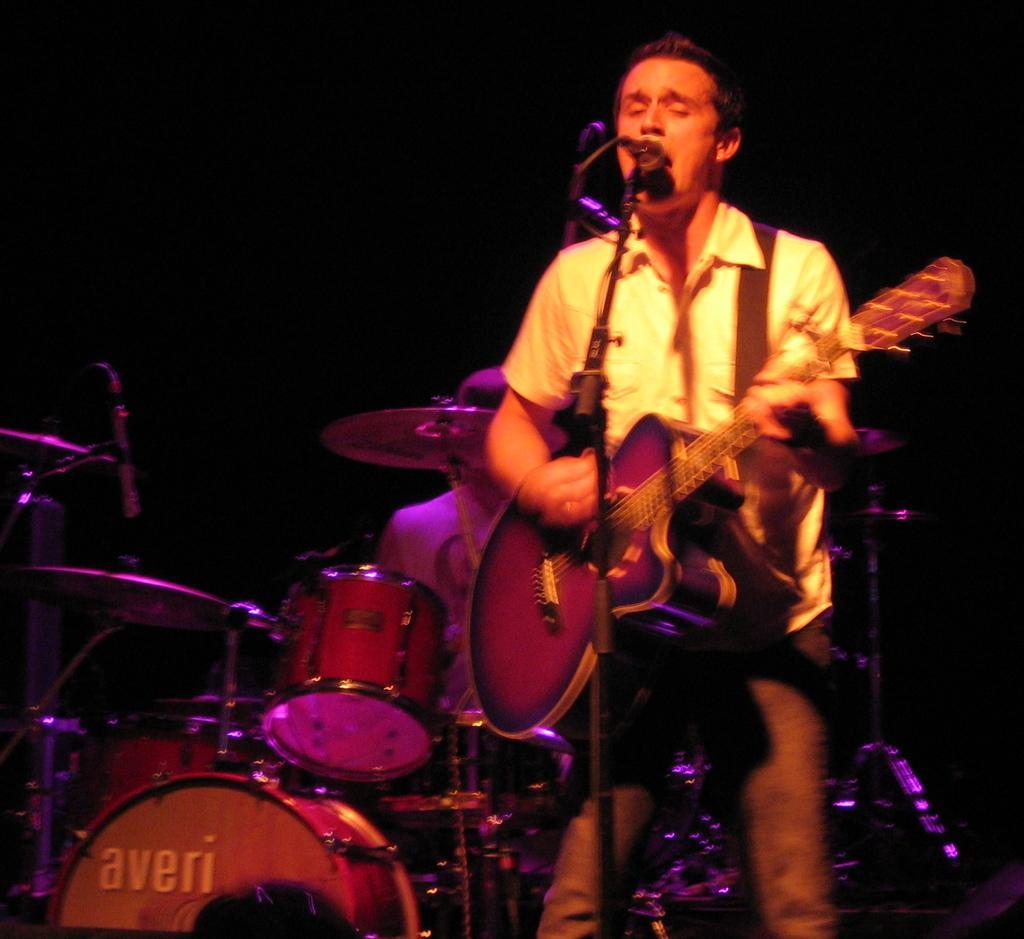Can you describe this image briefly? In this image I see a man who is standing in front of a mic and he is holding a guitar, In the background I see another person who is near to the drums and I can see another mic over here and It is dark in the background. 